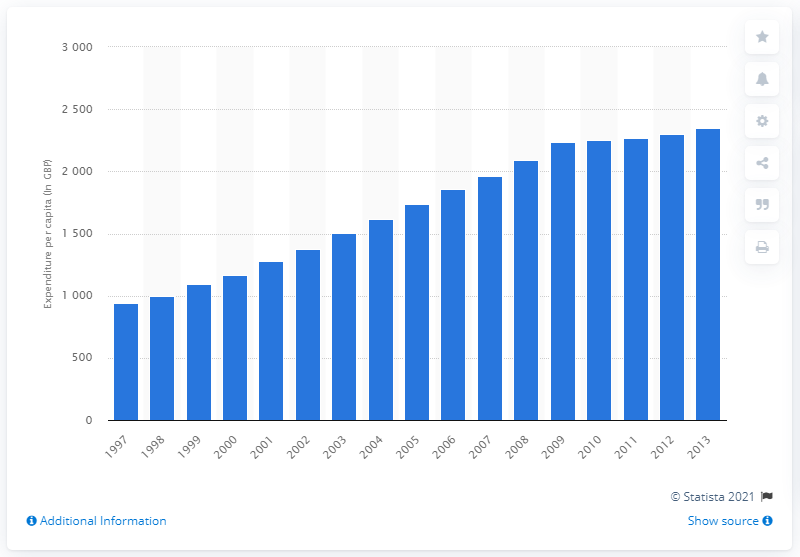Point out several critical features in this image. The global financial crisis occurred in 2009. 